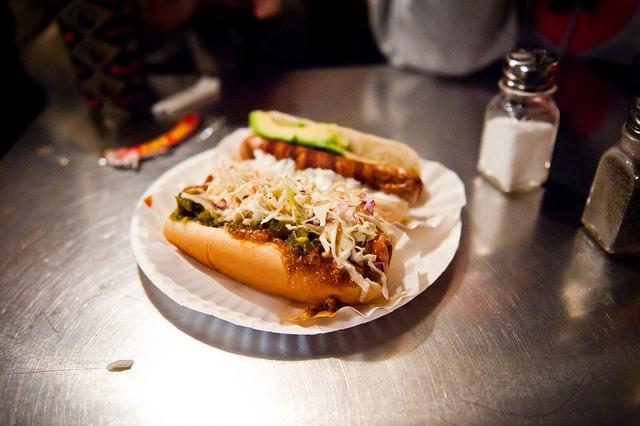What is the white toppings on the hot dog?
Concise answer only. Sauerkraut. Does this meal appear to be homemade?
Short answer required. No. How many hotdogs are on the plate?
Concise answer only. 2. Is the plate real?
Keep it brief. Yes. Is there a salad included with this meal?
Write a very short answer. No. What kind of plate is this?
Short answer required. Paper. Are there any fried onions on the hot dogs?
Be succinct. No. Is this a healthy meal?
Write a very short answer. No. What food is on the paper plates?
Quick response, please. Hot dogs. What is included in the meal?
Be succinct. Hot dogs. What kind of plate is the food served on?
Keep it brief. Paper. How many hot dogs are on the plate?
Quick response, please. 2. 